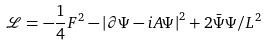Convert formula to latex. <formula><loc_0><loc_0><loc_500><loc_500>\mathcal { L } = - \frac { 1 } { 4 } F ^ { 2 } - \left | \partial \Psi - i A \Psi \right | ^ { 2 } + 2 \bar { \Psi } \Psi / L ^ { 2 }</formula> 